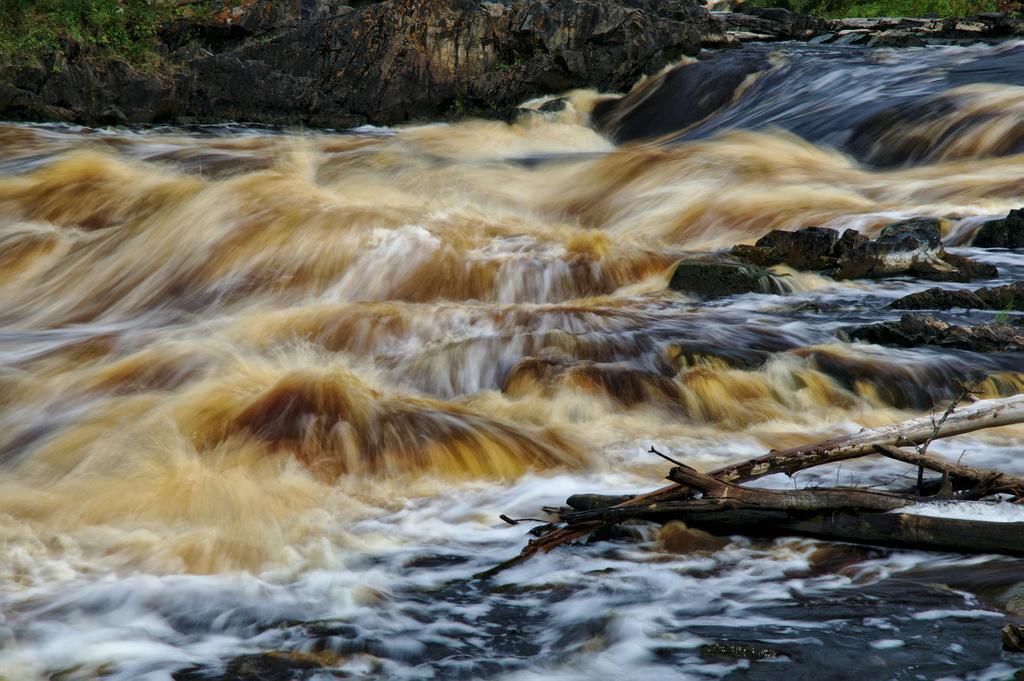Can you describe this image briefly? In this image I can see the water, wooden branches and plants. 